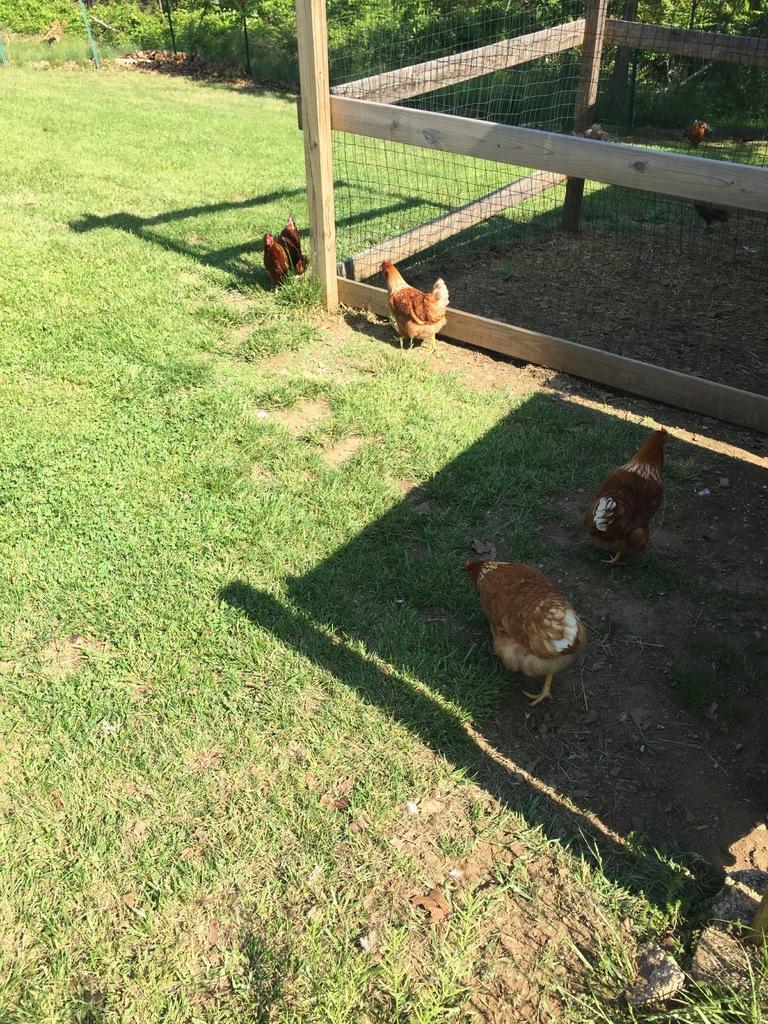Could you give a brief overview of what you see in this image? In this picture we can see many hens who are standing on the ground. On the top right we can see the wooden box room which is covered with the net. In the background we can see many trees. On the left we can see the green grass. 